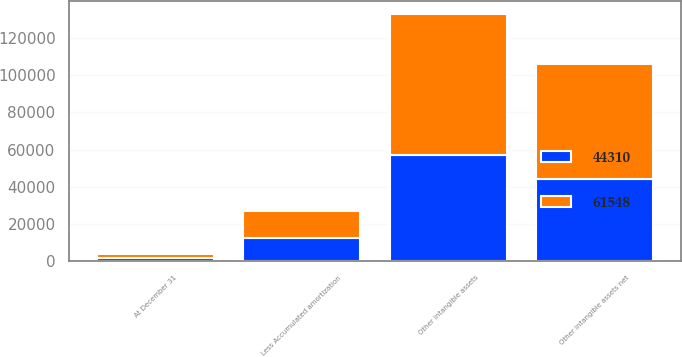Convert chart to OTSL. <chart><loc_0><loc_0><loc_500><loc_500><stacked_bar_chart><ecel><fcel>At December 31<fcel>Other intangible assets<fcel>Less Accumulated amortization<fcel>Other intangible assets net<nl><fcel>61548<fcel>2017<fcel>75780<fcel>14232<fcel>61548<nl><fcel>44310<fcel>2016<fcel>56937<fcel>12627<fcel>44310<nl></chart> 